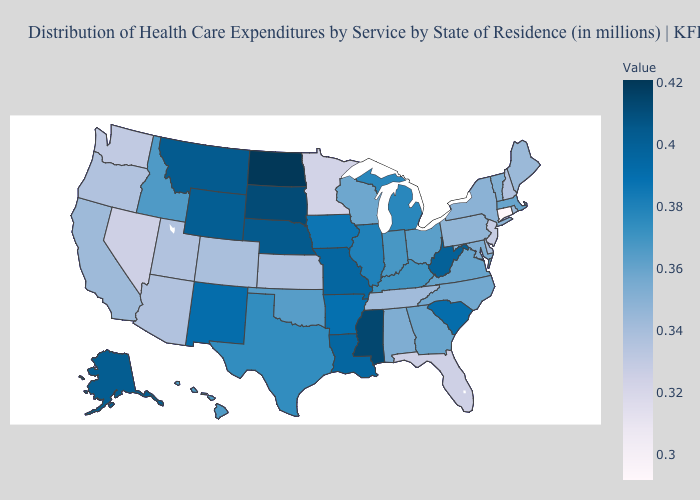Among the states that border Kansas , which have the lowest value?
Answer briefly. Colorado. Does South Carolina have a higher value than Alabama?
Write a very short answer. Yes. Which states hav the highest value in the West?
Quick response, please. Montana. Which states have the highest value in the USA?
Be succinct. North Dakota. 